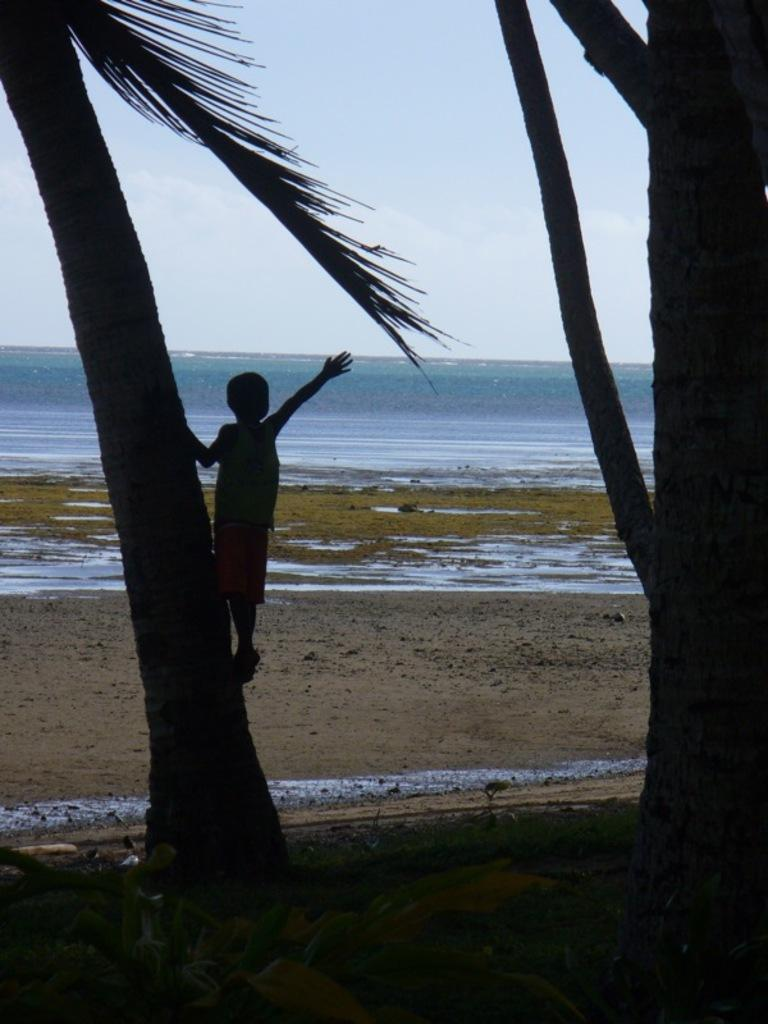Who is the main subject in the image? There is a boy in the image. What is the boy doing in the image? The boy is climbing a tree. Are there any other trees visible in the image? Yes, there is another tree visible in the image. What else can be seen in the image besides the trees? There is water visible in the image. How would you describe the weather in the image? The sky is cloudy in the image. What type of jam is the boy eating while climbing the tree in the image? There is no jam present in the image, and the boy is not eating anything while climbing the tree. 